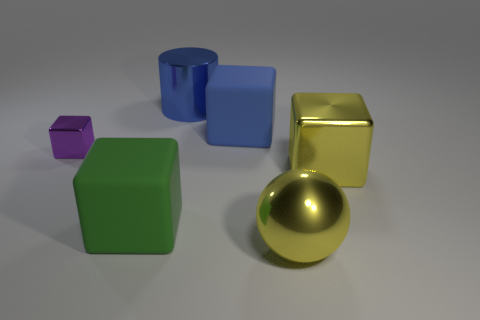Subtract all purple metal cubes. How many cubes are left? 3 Add 3 red cubes. How many objects exist? 9 Subtract all purple cubes. How many cubes are left? 3 Subtract 1 blocks. How many blocks are left? 3 Subtract all brown cubes. Subtract all yellow cylinders. How many cubes are left? 4 Subtract all blue matte things. Subtract all big rubber objects. How many objects are left? 3 Add 5 small shiny objects. How many small shiny objects are left? 6 Add 1 big brown shiny cylinders. How many big brown shiny cylinders exist? 1 Subtract 1 yellow blocks. How many objects are left? 5 Subtract all cylinders. How many objects are left? 5 